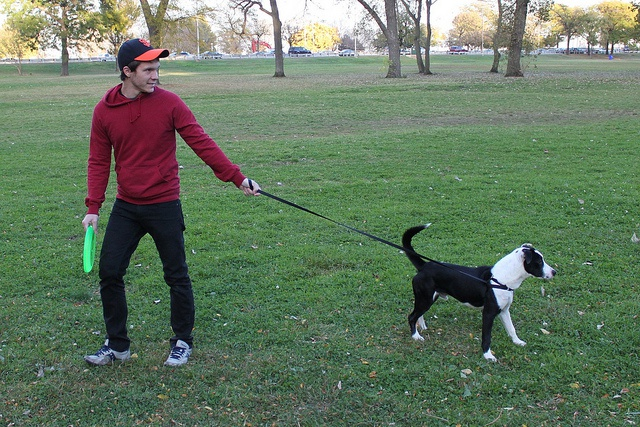Describe the objects in this image and their specific colors. I can see people in khaki, black, maroon, purple, and gray tones, dog in khaki, black, lavender, teal, and darkgray tones, frisbee in khaki, lightgreen, and green tones, car in khaki, gray, and darkgray tones, and car in khaki, darkgray, lightgray, and gray tones in this image. 